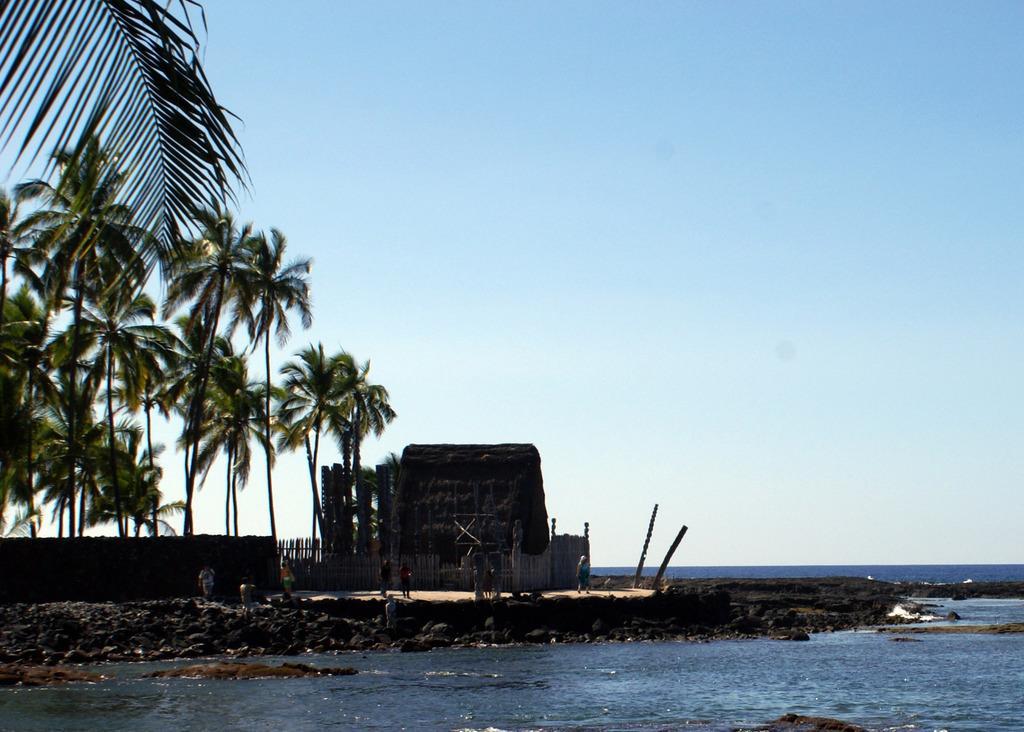How would you summarize this image in a sentence or two? In this picture we can see few people standing on the path. There is a house and fencing is visible around the house. We can see a compound wall and few trees on left side. Water is visible in the background. 